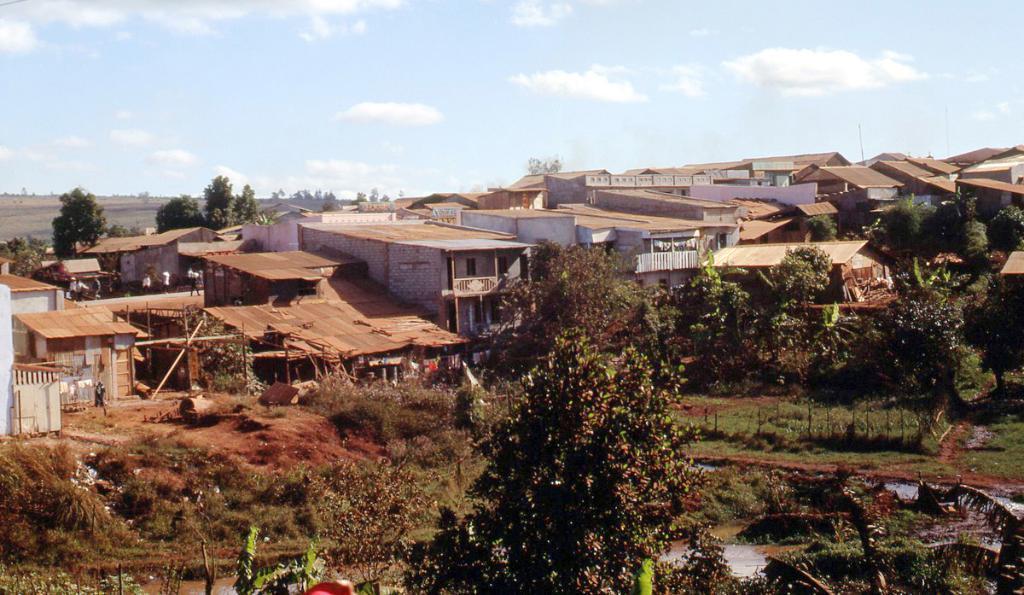Can you describe this image briefly? In this picture we can see there are trees, houses and some people on the path. Behind the houses there is a sky. 